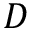Convert formula to latex. <formula><loc_0><loc_0><loc_500><loc_500>D</formula> 